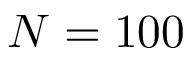<formula> <loc_0><loc_0><loc_500><loc_500>N = 1 0 0</formula> 